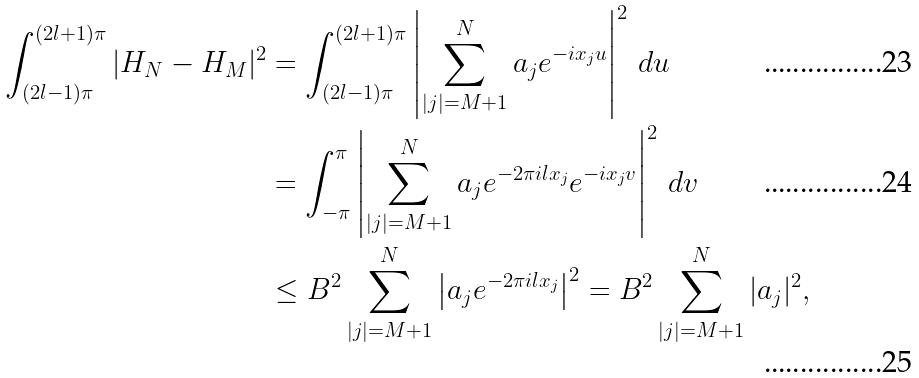Convert formula to latex. <formula><loc_0><loc_0><loc_500><loc_500>\int _ { ( 2 l - 1 ) \pi } ^ { ( 2 l + 1 ) \pi } | H _ { N } - H _ { M } | ^ { 2 } & = \int _ { ( 2 l - 1 ) \pi } ^ { ( 2 l + 1 ) \pi } \left | \sum _ { | j | = M + 1 } ^ { N } a _ { j } e ^ { - i x _ { j } u } \right | ^ { 2 } \, d u \\ & = \int _ { - \pi } ^ { \pi } \left | \sum _ { | j | = M + 1 } ^ { N } a _ { j } e ^ { - 2 \pi i l x _ { j } } e ^ { - i x _ { j } v } \right | ^ { 2 } \, d v \\ & \leq B ^ { 2 } \sum _ { | j | = M + 1 } ^ { N } \left | a _ { j } e ^ { - 2 \pi i l x _ { j } } \right | ^ { 2 } = B ^ { 2 } \sum _ { | j | = M + 1 } ^ { N } | a _ { j } | ^ { 2 } ,</formula> 